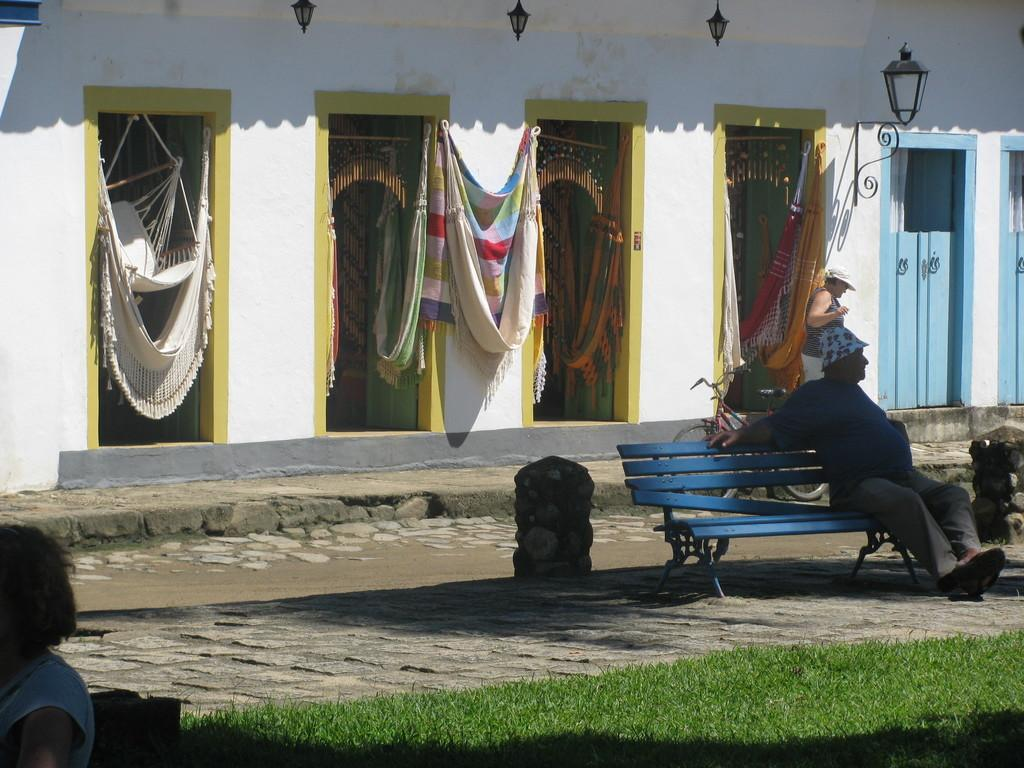What is the state of the door in the image? There is an open door in the image. What can be seen near the door? Curtains are hanging near the door. What is located behind the door? There is a seat behind the door. Who is sitting on the seat? A man is sitting on the seat. What type of natural formation is present in the image? There is a rock pillar in the image. How many frogs are hopping on the rock pillar in the image? There are no frogs present in the image, so it is not possible to determine the number of frogs hopping on the rock pillar. 